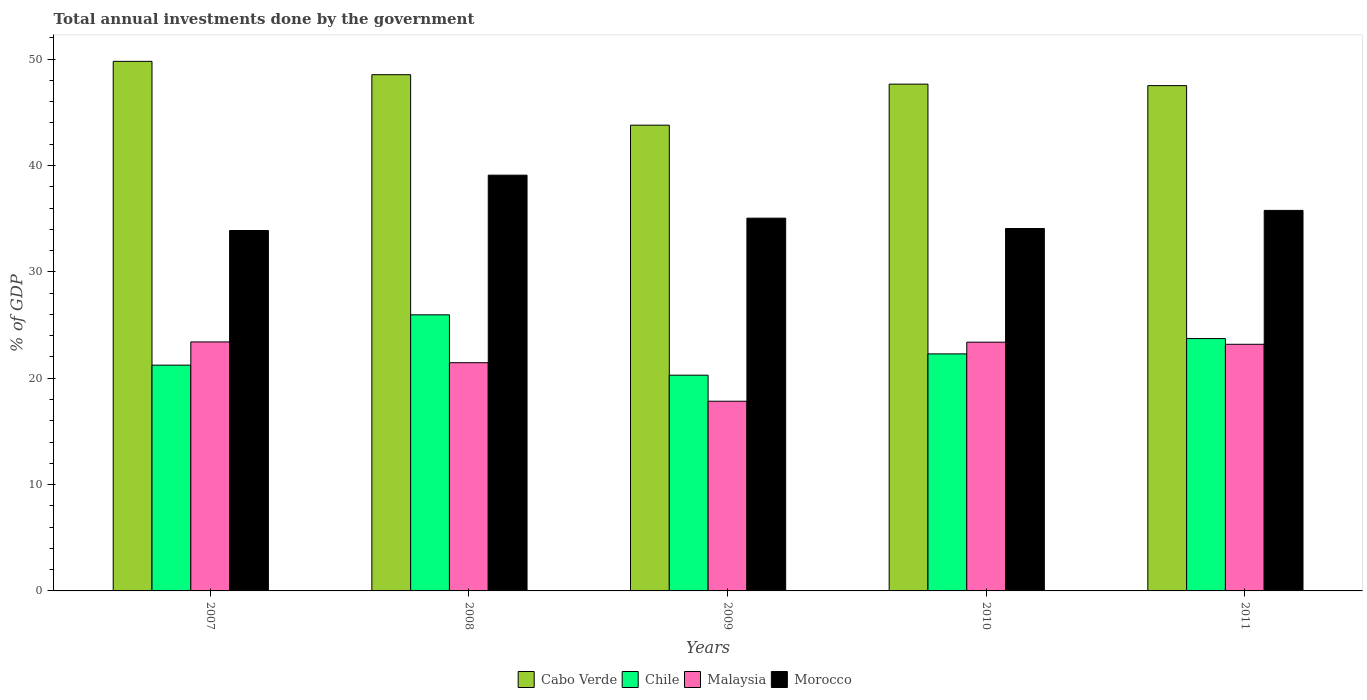How many groups of bars are there?
Ensure brevity in your answer.  5. Are the number of bars per tick equal to the number of legend labels?
Your answer should be compact. Yes. How many bars are there on the 5th tick from the left?
Provide a succinct answer. 4. How many bars are there on the 5th tick from the right?
Offer a very short reply. 4. What is the label of the 2nd group of bars from the left?
Keep it short and to the point. 2008. What is the total annual investments done by the government in Morocco in 2010?
Provide a succinct answer. 34.07. Across all years, what is the maximum total annual investments done by the government in Malaysia?
Ensure brevity in your answer.  23.41. Across all years, what is the minimum total annual investments done by the government in Chile?
Ensure brevity in your answer.  20.28. In which year was the total annual investments done by the government in Morocco maximum?
Keep it short and to the point. 2008. In which year was the total annual investments done by the government in Malaysia minimum?
Offer a terse response. 2009. What is the total total annual investments done by the government in Chile in the graph?
Your response must be concise. 113.48. What is the difference between the total annual investments done by the government in Morocco in 2007 and that in 2009?
Your answer should be very brief. -1.16. What is the difference between the total annual investments done by the government in Chile in 2011 and the total annual investments done by the government in Morocco in 2007?
Provide a succinct answer. -10.16. What is the average total annual investments done by the government in Cabo Verde per year?
Offer a terse response. 47.45. In the year 2011, what is the difference between the total annual investments done by the government in Morocco and total annual investments done by the government in Chile?
Offer a terse response. 12.05. What is the ratio of the total annual investments done by the government in Malaysia in 2009 to that in 2011?
Offer a terse response. 0.77. Is the difference between the total annual investments done by the government in Morocco in 2010 and 2011 greater than the difference between the total annual investments done by the government in Chile in 2010 and 2011?
Keep it short and to the point. No. What is the difference between the highest and the second highest total annual investments done by the government in Morocco?
Offer a very short reply. 3.31. What is the difference between the highest and the lowest total annual investments done by the government in Chile?
Ensure brevity in your answer.  5.68. How many bars are there?
Your response must be concise. 20. Are all the bars in the graph horizontal?
Keep it short and to the point. No. Are the values on the major ticks of Y-axis written in scientific E-notation?
Give a very brief answer. No. Does the graph contain any zero values?
Your response must be concise. No. Where does the legend appear in the graph?
Keep it short and to the point. Bottom center. How many legend labels are there?
Your answer should be compact. 4. How are the legend labels stacked?
Provide a succinct answer. Horizontal. What is the title of the graph?
Your response must be concise. Total annual investments done by the government. What is the label or title of the Y-axis?
Ensure brevity in your answer.  % of GDP. What is the % of GDP in Cabo Verde in 2007?
Provide a succinct answer. 49.79. What is the % of GDP of Chile in 2007?
Provide a succinct answer. 21.23. What is the % of GDP in Malaysia in 2007?
Give a very brief answer. 23.41. What is the % of GDP in Morocco in 2007?
Offer a very short reply. 33.89. What is the % of GDP of Cabo Verde in 2008?
Your answer should be very brief. 48.54. What is the % of GDP in Chile in 2008?
Offer a very short reply. 25.96. What is the % of GDP in Malaysia in 2008?
Make the answer very short. 21.46. What is the % of GDP of Morocco in 2008?
Ensure brevity in your answer.  39.09. What is the % of GDP in Cabo Verde in 2009?
Provide a short and direct response. 43.79. What is the % of GDP of Chile in 2009?
Your answer should be compact. 20.28. What is the % of GDP of Malaysia in 2009?
Your answer should be compact. 17.84. What is the % of GDP in Morocco in 2009?
Offer a terse response. 35.05. What is the % of GDP of Cabo Verde in 2010?
Your answer should be compact. 47.65. What is the % of GDP in Chile in 2010?
Your response must be concise. 22.29. What is the % of GDP in Malaysia in 2010?
Your answer should be compact. 23.39. What is the % of GDP in Morocco in 2010?
Your answer should be compact. 34.07. What is the % of GDP of Cabo Verde in 2011?
Offer a very short reply. 47.51. What is the % of GDP of Chile in 2011?
Your answer should be compact. 23.73. What is the % of GDP in Malaysia in 2011?
Offer a terse response. 23.19. What is the % of GDP in Morocco in 2011?
Offer a terse response. 35.78. Across all years, what is the maximum % of GDP of Cabo Verde?
Make the answer very short. 49.79. Across all years, what is the maximum % of GDP of Chile?
Your answer should be very brief. 25.96. Across all years, what is the maximum % of GDP of Malaysia?
Your response must be concise. 23.41. Across all years, what is the maximum % of GDP of Morocco?
Make the answer very short. 39.09. Across all years, what is the minimum % of GDP in Cabo Verde?
Offer a very short reply. 43.79. Across all years, what is the minimum % of GDP of Chile?
Provide a short and direct response. 20.28. Across all years, what is the minimum % of GDP in Malaysia?
Your answer should be compact. 17.84. Across all years, what is the minimum % of GDP in Morocco?
Provide a succinct answer. 33.89. What is the total % of GDP in Cabo Verde in the graph?
Give a very brief answer. 237.27. What is the total % of GDP in Chile in the graph?
Provide a succinct answer. 113.48. What is the total % of GDP of Malaysia in the graph?
Offer a terse response. 109.28. What is the total % of GDP in Morocco in the graph?
Your answer should be very brief. 177.87. What is the difference between the % of GDP in Cabo Verde in 2007 and that in 2008?
Provide a succinct answer. 1.25. What is the difference between the % of GDP in Chile in 2007 and that in 2008?
Your answer should be very brief. -4.73. What is the difference between the % of GDP of Malaysia in 2007 and that in 2008?
Keep it short and to the point. 1.95. What is the difference between the % of GDP of Morocco in 2007 and that in 2008?
Give a very brief answer. -5.2. What is the difference between the % of GDP of Cabo Verde in 2007 and that in 2009?
Offer a terse response. 6. What is the difference between the % of GDP of Chile in 2007 and that in 2009?
Ensure brevity in your answer.  0.94. What is the difference between the % of GDP in Malaysia in 2007 and that in 2009?
Give a very brief answer. 5.57. What is the difference between the % of GDP of Morocco in 2007 and that in 2009?
Provide a short and direct response. -1.16. What is the difference between the % of GDP in Cabo Verde in 2007 and that in 2010?
Provide a succinct answer. 2.14. What is the difference between the % of GDP in Chile in 2007 and that in 2010?
Give a very brief answer. -1.06. What is the difference between the % of GDP in Malaysia in 2007 and that in 2010?
Your response must be concise. 0.02. What is the difference between the % of GDP of Morocco in 2007 and that in 2010?
Provide a short and direct response. -0.19. What is the difference between the % of GDP of Cabo Verde in 2007 and that in 2011?
Make the answer very short. 2.28. What is the difference between the % of GDP in Chile in 2007 and that in 2011?
Make the answer very short. -2.5. What is the difference between the % of GDP in Malaysia in 2007 and that in 2011?
Offer a terse response. 0.22. What is the difference between the % of GDP of Morocco in 2007 and that in 2011?
Provide a succinct answer. -1.89. What is the difference between the % of GDP in Cabo Verde in 2008 and that in 2009?
Your answer should be compact. 4.75. What is the difference between the % of GDP of Chile in 2008 and that in 2009?
Your response must be concise. 5.68. What is the difference between the % of GDP of Malaysia in 2008 and that in 2009?
Your answer should be compact. 3.62. What is the difference between the % of GDP of Morocco in 2008 and that in 2009?
Your answer should be very brief. 4.04. What is the difference between the % of GDP in Cabo Verde in 2008 and that in 2010?
Offer a terse response. 0.89. What is the difference between the % of GDP in Chile in 2008 and that in 2010?
Your response must be concise. 3.67. What is the difference between the % of GDP in Malaysia in 2008 and that in 2010?
Your response must be concise. -1.93. What is the difference between the % of GDP in Morocco in 2008 and that in 2010?
Offer a terse response. 5.01. What is the difference between the % of GDP of Cabo Verde in 2008 and that in 2011?
Offer a terse response. 1.03. What is the difference between the % of GDP in Chile in 2008 and that in 2011?
Your response must be concise. 2.23. What is the difference between the % of GDP in Malaysia in 2008 and that in 2011?
Offer a terse response. -1.73. What is the difference between the % of GDP of Morocco in 2008 and that in 2011?
Your answer should be very brief. 3.31. What is the difference between the % of GDP in Cabo Verde in 2009 and that in 2010?
Your response must be concise. -3.86. What is the difference between the % of GDP in Chile in 2009 and that in 2010?
Your answer should be very brief. -2. What is the difference between the % of GDP in Malaysia in 2009 and that in 2010?
Make the answer very short. -5.55. What is the difference between the % of GDP of Morocco in 2009 and that in 2010?
Your response must be concise. 0.97. What is the difference between the % of GDP of Cabo Verde in 2009 and that in 2011?
Provide a short and direct response. -3.72. What is the difference between the % of GDP of Chile in 2009 and that in 2011?
Keep it short and to the point. -3.44. What is the difference between the % of GDP of Malaysia in 2009 and that in 2011?
Your answer should be compact. -5.35. What is the difference between the % of GDP in Morocco in 2009 and that in 2011?
Your response must be concise. -0.73. What is the difference between the % of GDP of Cabo Verde in 2010 and that in 2011?
Offer a terse response. 0.14. What is the difference between the % of GDP of Chile in 2010 and that in 2011?
Your response must be concise. -1.44. What is the difference between the % of GDP of Malaysia in 2010 and that in 2011?
Your answer should be compact. 0.2. What is the difference between the % of GDP in Morocco in 2010 and that in 2011?
Keep it short and to the point. -1.7. What is the difference between the % of GDP in Cabo Verde in 2007 and the % of GDP in Chile in 2008?
Your answer should be compact. 23.83. What is the difference between the % of GDP of Cabo Verde in 2007 and the % of GDP of Malaysia in 2008?
Your response must be concise. 28.33. What is the difference between the % of GDP in Cabo Verde in 2007 and the % of GDP in Morocco in 2008?
Your answer should be very brief. 10.7. What is the difference between the % of GDP in Chile in 2007 and the % of GDP in Malaysia in 2008?
Your response must be concise. -0.23. What is the difference between the % of GDP of Chile in 2007 and the % of GDP of Morocco in 2008?
Your answer should be compact. -17.86. What is the difference between the % of GDP in Malaysia in 2007 and the % of GDP in Morocco in 2008?
Provide a short and direct response. -15.68. What is the difference between the % of GDP in Cabo Verde in 2007 and the % of GDP in Chile in 2009?
Give a very brief answer. 29.51. What is the difference between the % of GDP in Cabo Verde in 2007 and the % of GDP in Malaysia in 2009?
Your answer should be very brief. 31.95. What is the difference between the % of GDP of Cabo Verde in 2007 and the % of GDP of Morocco in 2009?
Provide a short and direct response. 14.74. What is the difference between the % of GDP in Chile in 2007 and the % of GDP in Malaysia in 2009?
Offer a very short reply. 3.39. What is the difference between the % of GDP of Chile in 2007 and the % of GDP of Morocco in 2009?
Ensure brevity in your answer.  -13.82. What is the difference between the % of GDP in Malaysia in 2007 and the % of GDP in Morocco in 2009?
Ensure brevity in your answer.  -11.64. What is the difference between the % of GDP of Cabo Verde in 2007 and the % of GDP of Chile in 2010?
Keep it short and to the point. 27.5. What is the difference between the % of GDP in Cabo Verde in 2007 and the % of GDP in Malaysia in 2010?
Make the answer very short. 26.4. What is the difference between the % of GDP of Cabo Verde in 2007 and the % of GDP of Morocco in 2010?
Provide a short and direct response. 15.72. What is the difference between the % of GDP in Chile in 2007 and the % of GDP in Malaysia in 2010?
Give a very brief answer. -2.16. What is the difference between the % of GDP in Chile in 2007 and the % of GDP in Morocco in 2010?
Your answer should be compact. -12.85. What is the difference between the % of GDP of Malaysia in 2007 and the % of GDP of Morocco in 2010?
Give a very brief answer. -10.66. What is the difference between the % of GDP in Cabo Verde in 2007 and the % of GDP in Chile in 2011?
Give a very brief answer. 26.06. What is the difference between the % of GDP in Cabo Verde in 2007 and the % of GDP in Malaysia in 2011?
Keep it short and to the point. 26.6. What is the difference between the % of GDP of Cabo Verde in 2007 and the % of GDP of Morocco in 2011?
Provide a short and direct response. 14.01. What is the difference between the % of GDP of Chile in 2007 and the % of GDP of Malaysia in 2011?
Your answer should be compact. -1.96. What is the difference between the % of GDP in Chile in 2007 and the % of GDP in Morocco in 2011?
Your answer should be compact. -14.55. What is the difference between the % of GDP in Malaysia in 2007 and the % of GDP in Morocco in 2011?
Give a very brief answer. -12.37. What is the difference between the % of GDP in Cabo Verde in 2008 and the % of GDP in Chile in 2009?
Offer a terse response. 28.25. What is the difference between the % of GDP of Cabo Verde in 2008 and the % of GDP of Malaysia in 2009?
Make the answer very short. 30.7. What is the difference between the % of GDP of Cabo Verde in 2008 and the % of GDP of Morocco in 2009?
Your answer should be compact. 13.49. What is the difference between the % of GDP of Chile in 2008 and the % of GDP of Malaysia in 2009?
Provide a succinct answer. 8.12. What is the difference between the % of GDP of Chile in 2008 and the % of GDP of Morocco in 2009?
Your answer should be very brief. -9.09. What is the difference between the % of GDP of Malaysia in 2008 and the % of GDP of Morocco in 2009?
Your answer should be compact. -13.59. What is the difference between the % of GDP in Cabo Verde in 2008 and the % of GDP in Chile in 2010?
Your answer should be compact. 26.25. What is the difference between the % of GDP in Cabo Verde in 2008 and the % of GDP in Malaysia in 2010?
Your response must be concise. 25.15. What is the difference between the % of GDP in Cabo Verde in 2008 and the % of GDP in Morocco in 2010?
Your answer should be very brief. 14.46. What is the difference between the % of GDP in Chile in 2008 and the % of GDP in Malaysia in 2010?
Keep it short and to the point. 2.57. What is the difference between the % of GDP in Chile in 2008 and the % of GDP in Morocco in 2010?
Provide a short and direct response. -8.12. What is the difference between the % of GDP of Malaysia in 2008 and the % of GDP of Morocco in 2010?
Make the answer very short. -12.62. What is the difference between the % of GDP in Cabo Verde in 2008 and the % of GDP in Chile in 2011?
Provide a short and direct response. 24.81. What is the difference between the % of GDP in Cabo Verde in 2008 and the % of GDP in Malaysia in 2011?
Give a very brief answer. 25.35. What is the difference between the % of GDP in Cabo Verde in 2008 and the % of GDP in Morocco in 2011?
Offer a very short reply. 12.76. What is the difference between the % of GDP of Chile in 2008 and the % of GDP of Malaysia in 2011?
Your answer should be compact. 2.77. What is the difference between the % of GDP of Chile in 2008 and the % of GDP of Morocco in 2011?
Offer a terse response. -9.82. What is the difference between the % of GDP of Malaysia in 2008 and the % of GDP of Morocco in 2011?
Your answer should be very brief. -14.32. What is the difference between the % of GDP of Cabo Verde in 2009 and the % of GDP of Chile in 2010?
Provide a succinct answer. 21.5. What is the difference between the % of GDP in Cabo Verde in 2009 and the % of GDP in Malaysia in 2010?
Offer a terse response. 20.4. What is the difference between the % of GDP in Cabo Verde in 2009 and the % of GDP in Morocco in 2010?
Provide a short and direct response. 9.71. What is the difference between the % of GDP in Chile in 2009 and the % of GDP in Malaysia in 2010?
Offer a very short reply. -3.1. What is the difference between the % of GDP in Chile in 2009 and the % of GDP in Morocco in 2010?
Ensure brevity in your answer.  -13.79. What is the difference between the % of GDP of Malaysia in 2009 and the % of GDP of Morocco in 2010?
Provide a succinct answer. -16.24. What is the difference between the % of GDP of Cabo Verde in 2009 and the % of GDP of Chile in 2011?
Give a very brief answer. 20.06. What is the difference between the % of GDP of Cabo Verde in 2009 and the % of GDP of Malaysia in 2011?
Give a very brief answer. 20.6. What is the difference between the % of GDP in Cabo Verde in 2009 and the % of GDP in Morocco in 2011?
Offer a terse response. 8.01. What is the difference between the % of GDP in Chile in 2009 and the % of GDP in Malaysia in 2011?
Provide a short and direct response. -2.9. What is the difference between the % of GDP in Chile in 2009 and the % of GDP in Morocco in 2011?
Your response must be concise. -15.49. What is the difference between the % of GDP in Malaysia in 2009 and the % of GDP in Morocco in 2011?
Keep it short and to the point. -17.94. What is the difference between the % of GDP in Cabo Verde in 2010 and the % of GDP in Chile in 2011?
Provide a short and direct response. 23.92. What is the difference between the % of GDP of Cabo Verde in 2010 and the % of GDP of Malaysia in 2011?
Offer a terse response. 24.46. What is the difference between the % of GDP in Cabo Verde in 2010 and the % of GDP in Morocco in 2011?
Your response must be concise. 11.87. What is the difference between the % of GDP of Chile in 2010 and the % of GDP of Malaysia in 2011?
Keep it short and to the point. -0.9. What is the difference between the % of GDP of Chile in 2010 and the % of GDP of Morocco in 2011?
Offer a very short reply. -13.49. What is the difference between the % of GDP in Malaysia in 2010 and the % of GDP in Morocco in 2011?
Your answer should be compact. -12.39. What is the average % of GDP in Cabo Verde per year?
Provide a short and direct response. 47.45. What is the average % of GDP of Chile per year?
Offer a terse response. 22.7. What is the average % of GDP in Malaysia per year?
Ensure brevity in your answer.  21.86. What is the average % of GDP in Morocco per year?
Provide a short and direct response. 35.57. In the year 2007, what is the difference between the % of GDP of Cabo Verde and % of GDP of Chile?
Ensure brevity in your answer.  28.56. In the year 2007, what is the difference between the % of GDP of Cabo Verde and % of GDP of Malaysia?
Offer a very short reply. 26.38. In the year 2007, what is the difference between the % of GDP in Cabo Verde and % of GDP in Morocco?
Your answer should be very brief. 15.9. In the year 2007, what is the difference between the % of GDP in Chile and % of GDP in Malaysia?
Make the answer very short. -2.18. In the year 2007, what is the difference between the % of GDP in Chile and % of GDP in Morocco?
Ensure brevity in your answer.  -12.66. In the year 2007, what is the difference between the % of GDP in Malaysia and % of GDP in Morocco?
Your answer should be very brief. -10.48. In the year 2008, what is the difference between the % of GDP in Cabo Verde and % of GDP in Chile?
Make the answer very short. 22.58. In the year 2008, what is the difference between the % of GDP in Cabo Verde and % of GDP in Malaysia?
Your response must be concise. 27.08. In the year 2008, what is the difference between the % of GDP of Cabo Verde and % of GDP of Morocco?
Your answer should be very brief. 9.45. In the year 2008, what is the difference between the % of GDP in Chile and % of GDP in Malaysia?
Your response must be concise. 4.5. In the year 2008, what is the difference between the % of GDP of Chile and % of GDP of Morocco?
Offer a terse response. -13.13. In the year 2008, what is the difference between the % of GDP of Malaysia and % of GDP of Morocco?
Offer a very short reply. -17.63. In the year 2009, what is the difference between the % of GDP of Cabo Verde and % of GDP of Chile?
Give a very brief answer. 23.51. In the year 2009, what is the difference between the % of GDP in Cabo Verde and % of GDP in Malaysia?
Your answer should be very brief. 25.95. In the year 2009, what is the difference between the % of GDP in Cabo Verde and % of GDP in Morocco?
Offer a terse response. 8.74. In the year 2009, what is the difference between the % of GDP in Chile and % of GDP in Malaysia?
Your answer should be compact. 2.45. In the year 2009, what is the difference between the % of GDP of Chile and % of GDP of Morocco?
Keep it short and to the point. -14.76. In the year 2009, what is the difference between the % of GDP of Malaysia and % of GDP of Morocco?
Offer a terse response. -17.21. In the year 2010, what is the difference between the % of GDP of Cabo Verde and % of GDP of Chile?
Ensure brevity in your answer.  25.36. In the year 2010, what is the difference between the % of GDP of Cabo Verde and % of GDP of Malaysia?
Keep it short and to the point. 24.26. In the year 2010, what is the difference between the % of GDP in Cabo Verde and % of GDP in Morocco?
Make the answer very short. 13.57. In the year 2010, what is the difference between the % of GDP in Chile and % of GDP in Malaysia?
Keep it short and to the point. -1.1. In the year 2010, what is the difference between the % of GDP of Chile and % of GDP of Morocco?
Make the answer very short. -11.79. In the year 2010, what is the difference between the % of GDP of Malaysia and % of GDP of Morocco?
Offer a terse response. -10.69. In the year 2011, what is the difference between the % of GDP in Cabo Verde and % of GDP in Chile?
Offer a very short reply. 23.78. In the year 2011, what is the difference between the % of GDP in Cabo Verde and % of GDP in Malaysia?
Your answer should be compact. 24.32. In the year 2011, what is the difference between the % of GDP of Cabo Verde and % of GDP of Morocco?
Keep it short and to the point. 11.73. In the year 2011, what is the difference between the % of GDP in Chile and % of GDP in Malaysia?
Offer a very short reply. 0.54. In the year 2011, what is the difference between the % of GDP in Chile and % of GDP in Morocco?
Provide a short and direct response. -12.05. In the year 2011, what is the difference between the % of GDP of Malaysia and % of GDP of Morocco?
Offer a very short reply. -12.59. What is the ratio of the % of GDP of Cabo Verde in 2007 to that in 2008?
Give a very brief answer. 1.03. What is the ratio of the % of GDP in Chile in 2007 to that in 2008?
Make the answer very short. 0.82. What is the ratio of the % of GDP in Morocco in 2007 to that in 2008?
Provide a succinct answer. 0.87. What is the ratio of the % of GDP of Cabo Verde in 2007 to that in 2009?
Offer a very short reply. 1.14. What is the ratio of the % of GDP of Chile in 2007 to that in 2009?
Keep it short and to the point. 1.05. What is the ratio of the % of GDP of Malaysia in 2007 to that in 2009?
Offer a terse response. 1.31. What is the ratio of the % of GDP in Morocco in 2007 to that in 2009?
Make the answer very short. 0.97. What is the ratio of the % of GDP of Cabo Verde in 2007 to that in 2010?
Your answer should be compact. 1.04. What is the ratio of the % of GDP in Cabo Verde in 2007 to that in 2011?
Ensure brevity in your answer.  1.05. What is the ratio of the % of GDP of Chile in 2007 to that in 2011?
Offer a very short reply. 0.89. What is the ratio of the % of GDP of Malaysia in 2007 to that in 2011?
Offer a terse response. 1.01. What is the ratio of the % of GDP of Morocco in 2007 to that in 2011?
Offer a very short reply. 0.95. What is the ratio of the % of GDP of Cabo Verde in 2008 to that in 2009?
Provide a succinct answer. 1.11. What is the ratio of the % of GDP in Chile in 2008 to that in 2009?
Ensure brevity in your answer.  1.28. What is the ratio of the % of GDP in Malaysia in 2008 to that in 2009?
Keep it short and to the point. 1.2. What is the ratio of the % of GDP of Morocco in 2008 to that in 2009?
Make the answer very short. 1.12. What is the ratio of the % of GDP in Cabo Verde in 2008 to that in 2010?
Your answer should be compact. 1.02. What is the ratio of the % of GDP in Chile in 2008 to that in 2010?
Offer a terse response. 1.16. What is the ratio of the % of GDP of Malaysia in 2008 to that in 2010?
Your response must be concise. 0.92. What is the ratio of the % of GDP of Morocco in 2008 to that in 2010?
Provide a succinct answer. 1.15. What is the ratio of the % of GDP of Cabo Verde in 2008 to that in 2011?
Make the answer very short. 1.02. What is the ratio of the % of GDP of Chile in 2008 to that in 2011?
Give a very brief answer. 1.09. What is the ratio of the % of GDP in Malaysia in 2008 to that in 2011?
Provide a short and direct response. 0.93. What is the ratio of the % of GDP in Morocco in 2008 to that in 2011?
Offer a very short reply. 1.09. What is the ratio of the % of GDP of Cabo Verde in 2009 to that in 2010?
Your answer should be compact. 0.92. What is the ratio of the % of GDP of Chile in 2009 to that in 2010?
Offer a terse response. 0.91. What is the ratio of the % of GDP of Malaysia in 2009 to that in 2010?
Provide a succinct answer. 0.76. What is the ratio of the % of GDP in Morocco in 2009 to that in 2010?
Provide a short and direct response. 1.03. What is the ratio of the % of GDP of Cabo Verde in 2009 to that in 2011?
Give a very brief answer. 0.92. What is the ratio of the % of GDP of Chile in 2009 to that in 2011?
Keep it short and to the point. 0.85. What is the ratio of the % of GDP of Malaysia in 2009 to that in 2011?
Ensure brevity in your answer.  0.77. What is the ratio of the % of GDP in Morocco in 2009 to that in 2011?
Your answer should be very brief. 0.98. What is the ratio of the % of GDP of Chile in 2010 to that in 2011?
Your answer should be compact. 0.94. What is the ratio of the % of GDP of Malaysia in 2010 to that in 2011?
Keep it short and to the point. 1.01. What is the difference between the highest and the second highest % of GDP in Cabo Verde?
Provide a short and direct response. 1.25. What is the difference between the highest and the second highest % of GDP in Chile?
Provide a short and direct response. 2.23. What is the difference between the highest and the second highest % of GDP of Malaysia?
Make the answer very short. 0.02. What is the difference between the highest and the second highest % of GDP of Morocco?
Offer a very short reply. 3.31. What is the difference between the highest and the lowest % of GDP of Cabo Verde?
Offer a very short reply. 6. What is the difference between the highest and the lowest % of GDP of Chile?
Make the answer very short. 5.68. What is the difference between the highest and the lowest % of GDP of Malaysia?
Ensure brevity in your answer.  5.57. What is the difference between the highest and the lowest % of GDP in Morocco?
Your response must be concise. 5.2. 